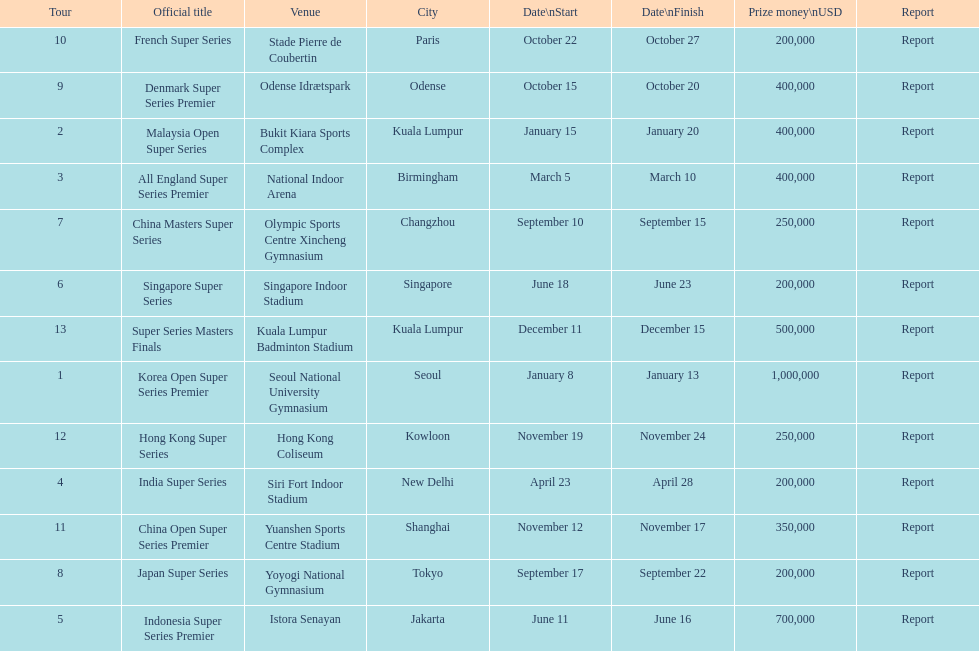How many occur in the last six months of the year? 7. 